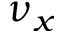Convert formula to latex. <formula><loc_0><loc_0><loc_500><loc_500>\nu _ { x }</formula> 